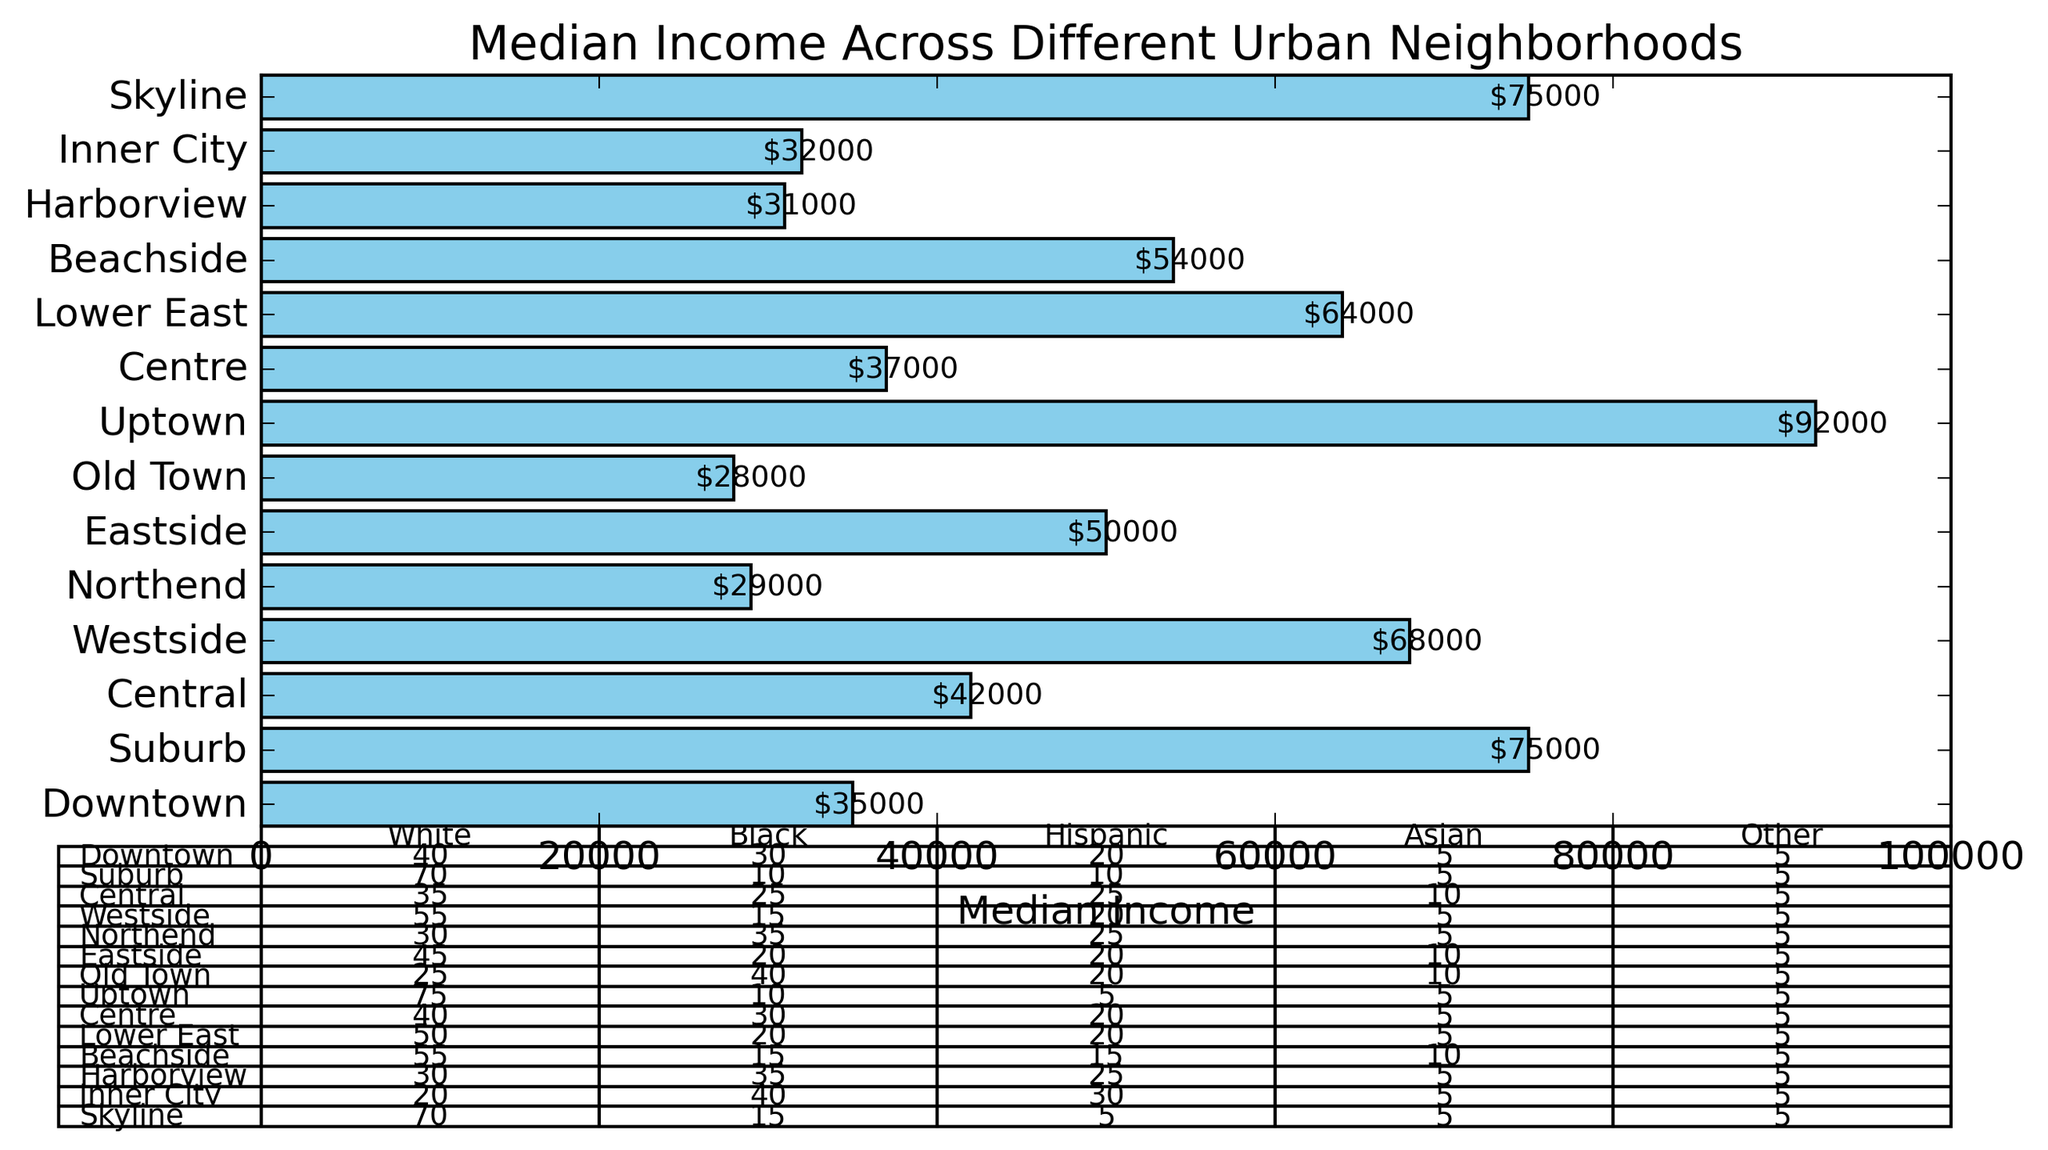What is the median income in Downtown, Metropolis? The bar representing Downtown in Metropolis shows the median income. By reading the value annotated on the bar, we see it's $35,000.
Answer: $35,000 Which neighborhood has the highest median income? Among all the neighborhoods represented by the bars, Uptown in Gotham has the longest bar with an annotated value of $92,000, indicating it has the highest median income.
Answer: Uptown, Gotham How does the median income of Beachside, Coast City compare to Inner City, Hub City? By visually comparing the lengths of the bars, Beachside in Coast City has a median income of $54,000, whereas Inner City in Hub City has a median income of $32,000. Beachside's median income is higher than Inner City’s.
Answer: Beachside's median income is higher Which neighborhood has the highest percentage of Black population? By examining the demographic breakdown table, Old Town in Gotham has the highest Black percentage of 40%.
Answer: Old Town, Gotham What is the average median income of all neighborhoods in Springfield? Springfield consists of Central and Westside neighborhoods. Central has a median income of $42,000, and Westside has a median income of $68,000. The average is calculated as (42,000 + 68,000) / 2 = $55,000.
Answer: $55,000 How does the population of Eastside in Riverside compare to Lower East in Star City? From the demographic data table, the population of Eastside in Riverside is 30,000, and the population of Lower East in Star City is 42,000. Lower East has a larger population.
Answer: Lower East, Star City has a larger population Which neighborhood in Coast City has the largest income disparity when comparing Quantile 1 and Quantile 4? Beachside's Quantile 1 income is $29,000, and Quantile 4 income is $85,000. Harborview's Quantile 1 income is $14,000, and Quantile 4 income is $45,000. The disparity for Beachside is 85,000 - 29,000 = $56,000, and for Harborview, it is 45,000 - 14,000 = $31,000. Beachside has the largest income disparity.
Answer: Beachside, Coast City What is the total percentage of Hispanic and Black population in Skyline, Hub City? Skyline’s Hispanic percentage is 5%, and the Black percentage is 15%. Adding them together gives 5 + 15 = 20%.
Answer: 20% Which neighborhood has the lowest median income in Metropolis? By comparing the bar lengths representing Metropolis neighborhoods, Downtown has a median income of $35,000, whereas Suburb has $75,000. Downtown has the lowest median income.
Answer: Downtown In Gotham, what is the difference in median income between Old Town and Uptown? Uptown has a median income of $92,000, and Old Town has $28,000. The difference is 92,000 - 28,000 = $64,000.
Answer: $64,000 